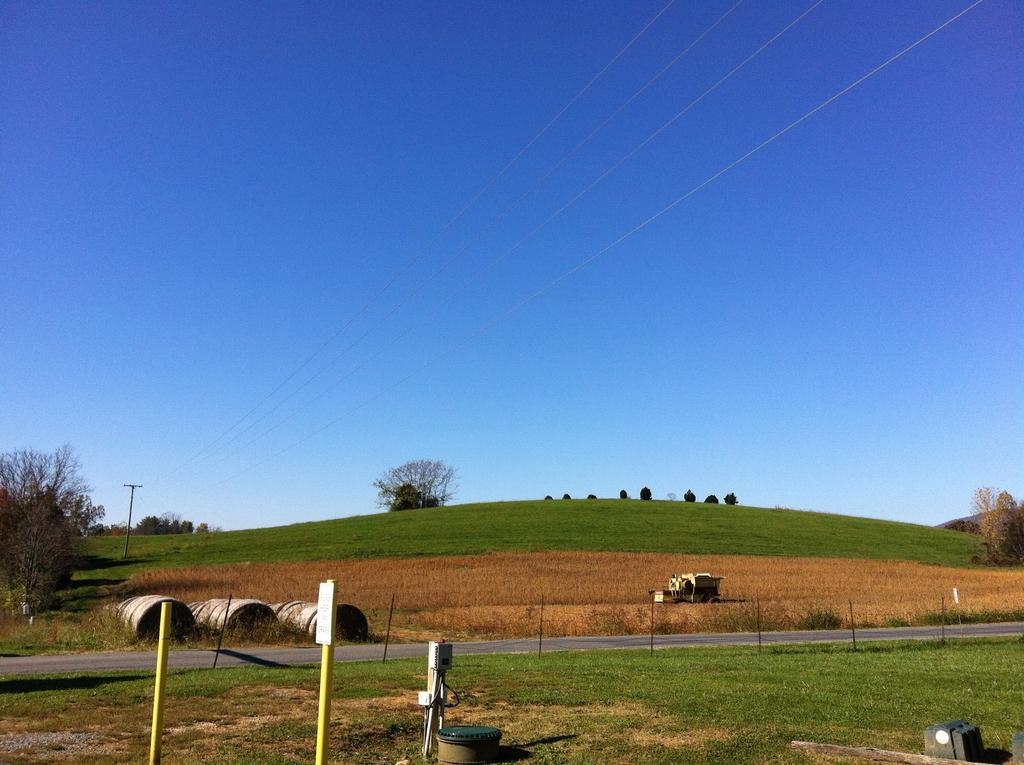What separates or defines the area in the image? There is a boundary in the image. What can be seen at the bottom side of the image? There are small sign poles at the bottom side of the image. What type of natural environment is visible in the image? There is greenery in the image. What can be seen at the top side of the image? There are wires at the top side of the image. What type of ornament is hanging from the wires in the image? There is no ornament hanging from the wires in the image; only wires are present. What type of learning can be observed in the image? There is no learning activity depicted in the image; it primarily features a boundary, sign poles, greenery, and wires. 